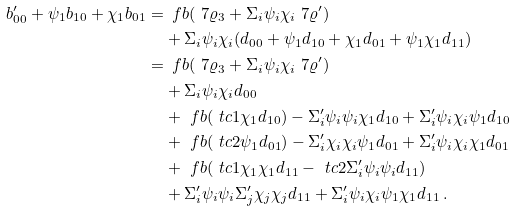<formula> <loc_0><loc_0><loc_500><loc_500>b ^ { \prime } _ { 0 0 } + \psi _ { 1 } b _ { 1 0 } + \chi _ { 1 } b _ { 0 1 } = & \, \ f b ( \ 7 \varrho _ { 3 } + \Sigma _ { i } \psi _ { i } \chi _ { i } \ 7 \varrho ^ { \prime } ) \\ & + \Sigma _ { i } \psi _ { i } \chi _ { i } ( d _ { 0 0 } + \psi _ { 1 } d _ { 1 0 } + \chi _ { 1 } d _ { 0 1 } + \psi _ { 1 } \chi _ { 1 } d _ { 1 1 } ) \\ = & \, \ f b ( \ 7 \varrho _ { 3 } + \Sigma _ { i } \psi _ { i } \chi _ { i } \ 7 \varrho ^ { \prime } ) \\ & + \Sigma _ { i } \psi _ { i } \chi _ { i } d _ { 0 0 } \\ & + \ f b ( \ t c 1 \chi _ { 1 } d _ { 1 0 } ) - \Sigma ^ { \prime } _ { i } \psi _ { i } \psi _ { i } \chi _ { 1 } d _ { 1 0 } + \Sigma ^ { \prime } _ { i } \psi _ { i } \chi _ { i } \psi _ { 1 } d _ { 1 0 } \\ & + \ f b ( \ t c 2 \psi _ { 1 } d _ { 0 1 } ) - \Sigma ^ { \prime } _ { i } \chi _ { i } \chi _ { i } \psi _ { 1 } d _ { 0 1 } + \Sigma ^ { \prime } _ { i } \psi _ { i } \chi _ { i } \chi _ { 1 } d _ { 0 1 } \\ & + \ f b ( \ t c 1 \chi _ { 1 } \chi _ { 1 } d _ { 1 1 } - \ t c 2 \Sigma ^ { \prime } _ { i } \psi _ { i } \psi _ { i } d _ { 1 1 } ) \\ & + \Sigma ^ { \prime } _ { i } \psi _ { i } \psi _ { i } \Sigma ^ { \prime } _ { j } \chi _ { j } \chi _ { j } d _ { 1 1 } + \Sigma ^ { \prime } _ { i } \psi _ { i } \chi _ { i } \psi _ { 1 } \chi _ { 1 } d _ { 1 1 } \, .</formula> 